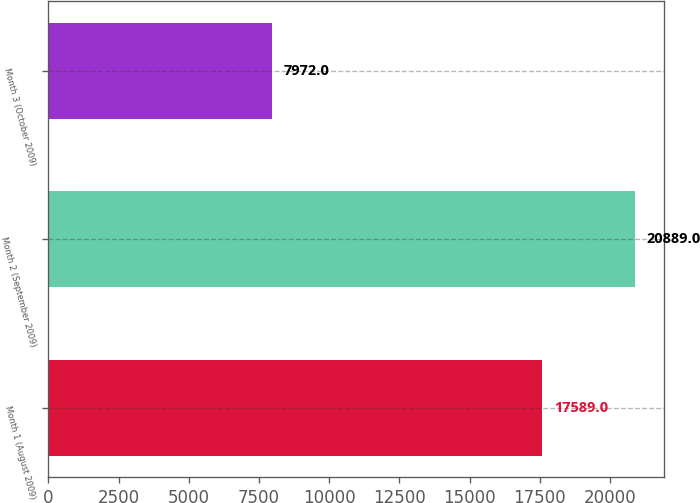Convert chart to OTSL. <chart><loc_0><loc_0><loc_500><loc_500><bar_chart><fcel>Month 1 (August 2009)<fcel>Month 2 (September 2009)<fcel>Month 3 (October 2009)<nl><fcel>17589<fcel>20889<fcel>7972<nl></chart> 